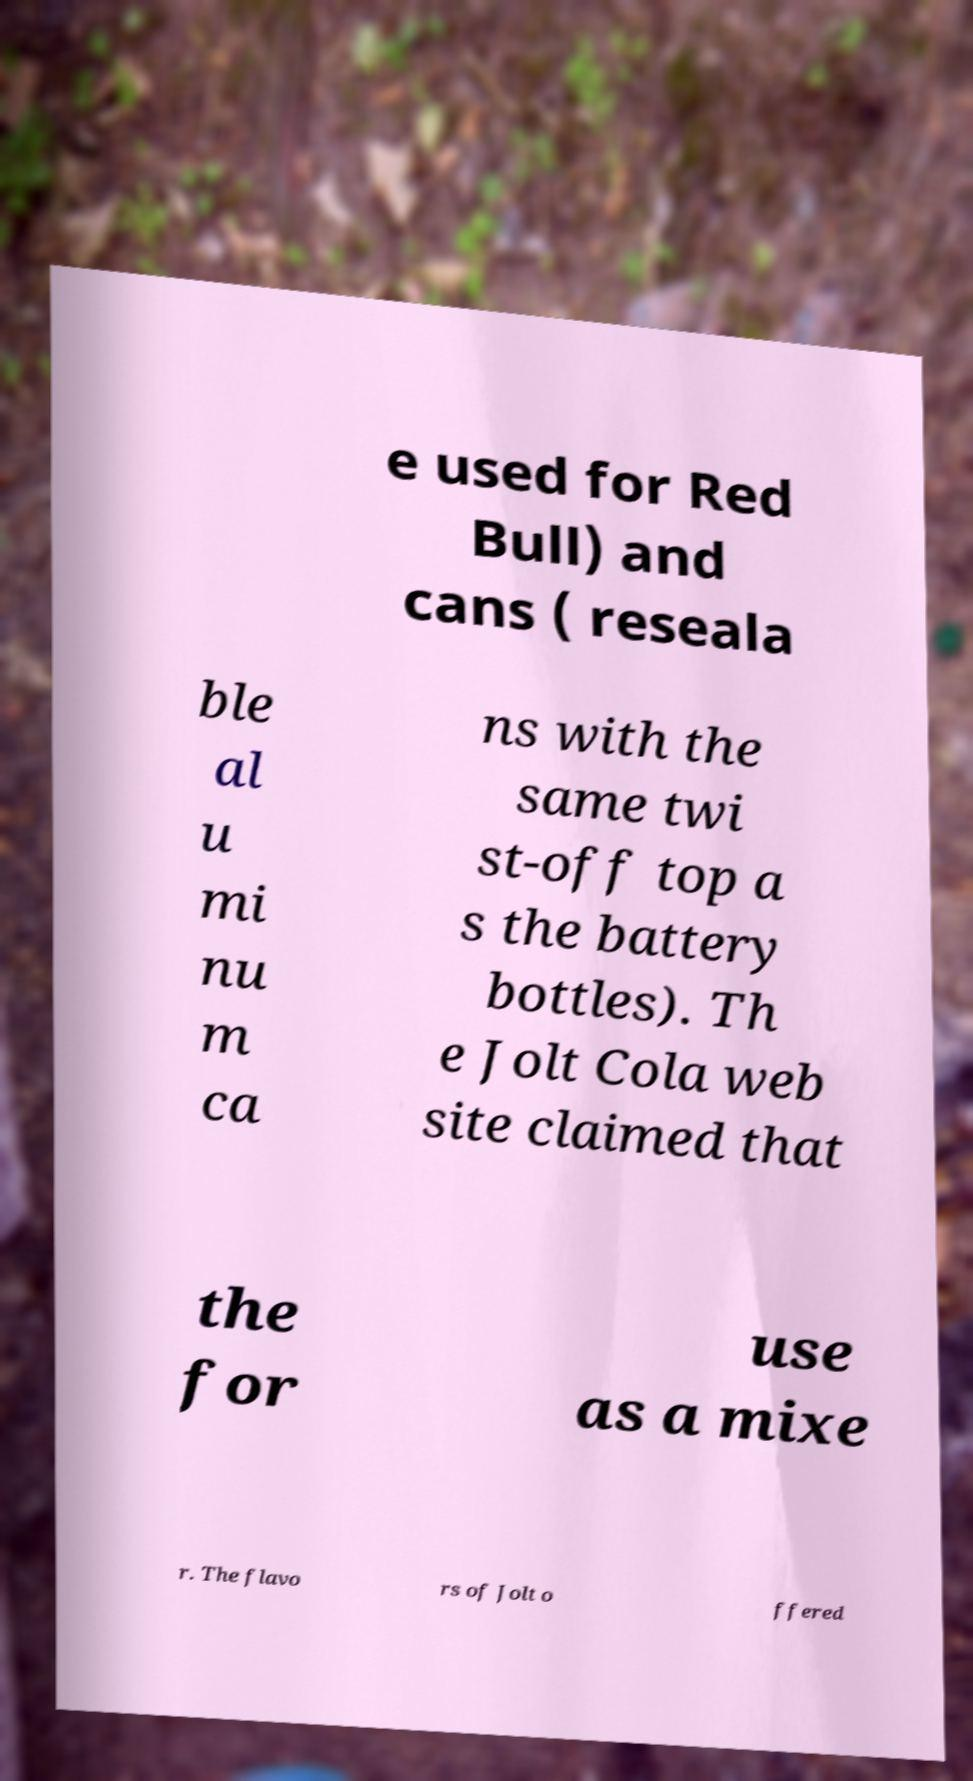I need the written content from this picture converted into text. Can you do that? e used for Red Bull) and cans ( reseala ble al u mi nu m ca ns with the same twi st-off top a s the battery bottles). Th e Jolt Cola web site claimed that the for use as a mixe r. The flavo rs of Jolt o ffered 